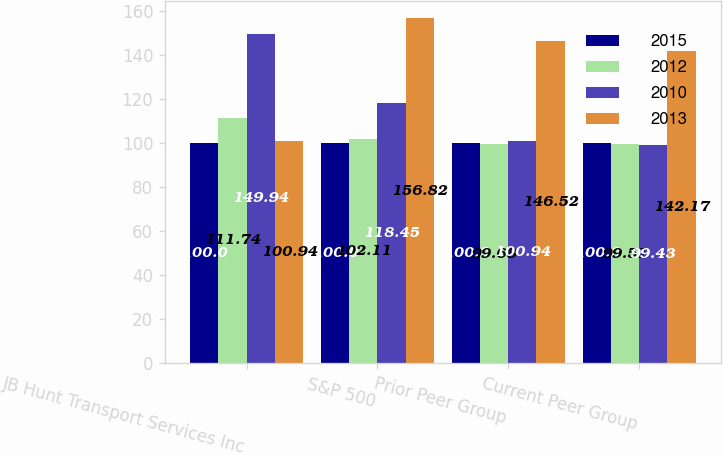Convert chart to OTSL. <chart><loc_0><loc_0><loc_500><loc_500><stacked_bar_chart><ecel><fcel>JB Hunt Transport Services Inc<fcel>S&P 500<fcel>Prior Peer Group<fcel>Current Peer Group<nl><fcel>2015<fcel>100<fcel>100<fcel>100<fcel>100<nl><fcel>2012<fcel>111.74<fcel>102.11<fcel>99.68<fcel>99.51<nl><fcel>2010<fcel>149.94<fcel>118.45<fcel>100.94<fcel>99.43<nl><fcel>2013<fcel>100.94<fcel>156.82<fcel>146.52<fcel>142.17<nl></chart> 